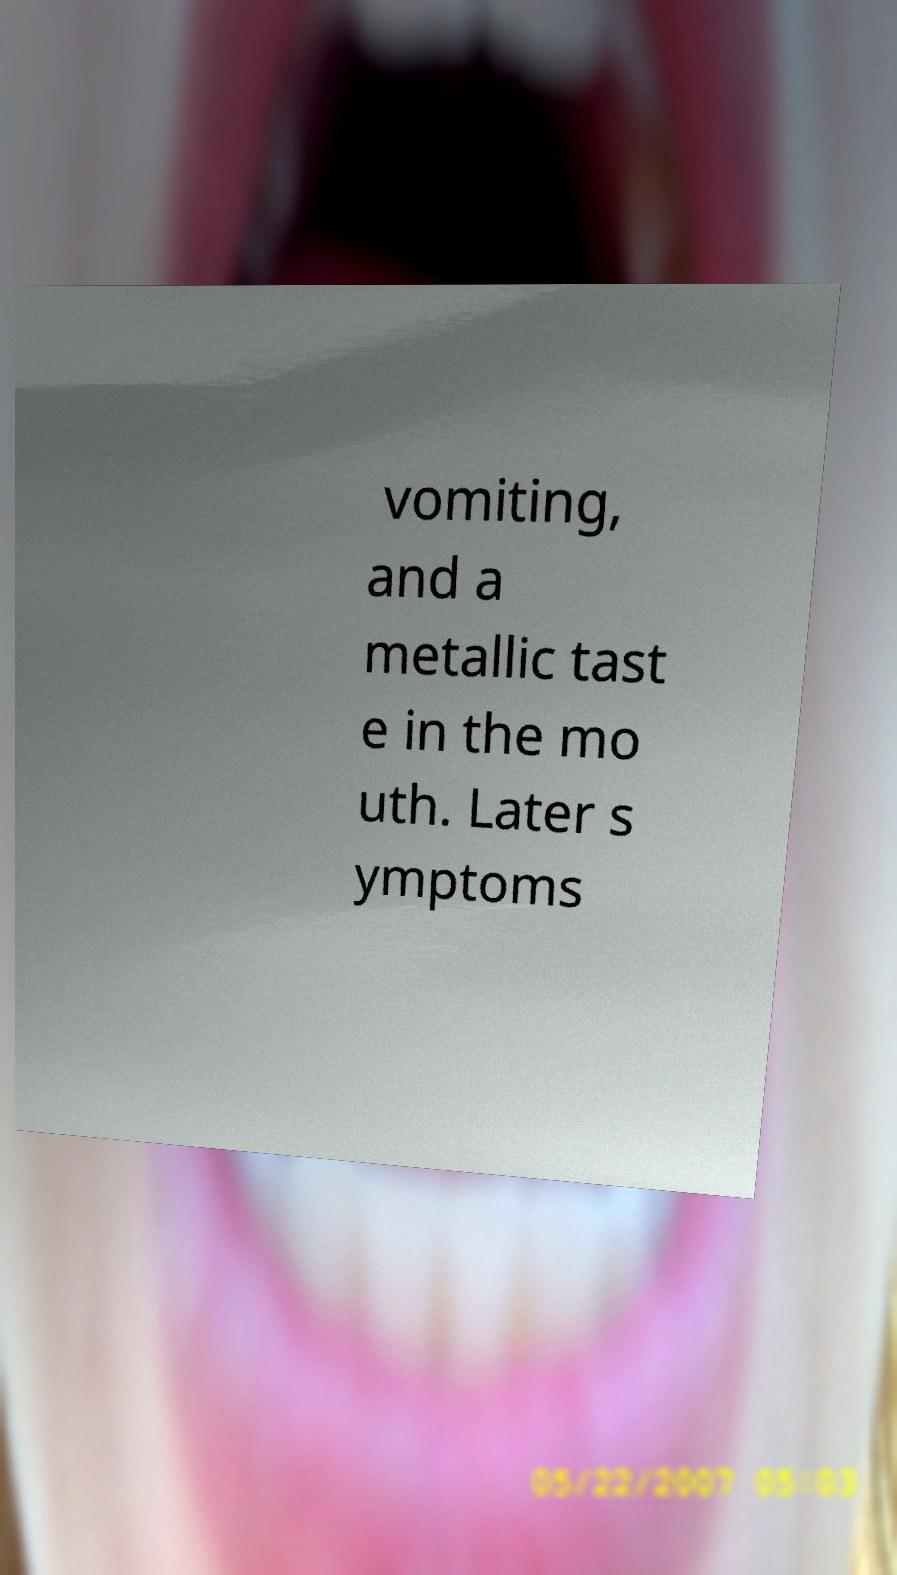Could you assist in decoding the text presented in this image and type it out clearly? vomiting, and a metallic tast e in the mo uth. Later s ymptoms 